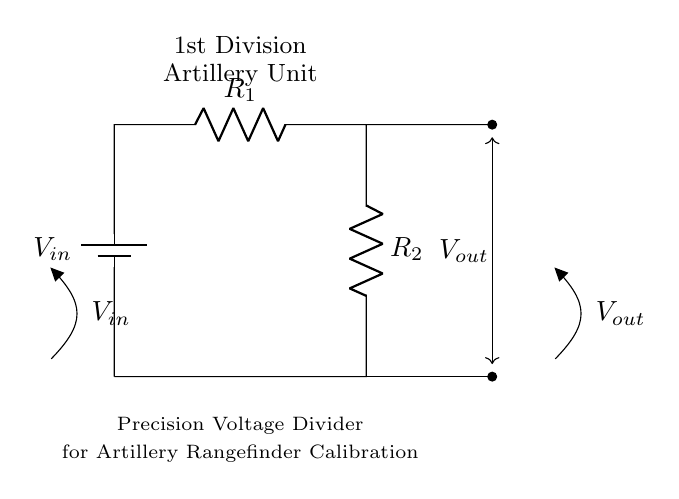What is the input voltage symbol in this circuit? The input voltage symbol is represented as V in the circuit diagram, which denotes the voltage supplied to the voltage divider.
Answer: V in What are the resistances in this precision voltage divider? The circuit shows two resistors connected in series, indicated as R1 and R2. These resistances are integral to determining the output voltage across R2.
Answer: R1, R2 What is the relationship between output voltage and input voltage? The output voltage V out is given by the formula: V out = (R2 / (R1 + R2)) * V in. This establishes how the division of input voltage occurs across the resistors based on their values.
Answer: Divider formula Where is the output voltage taken from in the circuit? The output voltage V out is taken between the two resistors, specifically across R2, as shown in the circuit connections.
Answer: Across R2 What type of circuit is this? This is a voltage divider circuit, which is specifically designed to output a fraction of the input voltage for various applications, including calibration in military equipment.
Answer: Voltage divider Why is precision important in this voltage divider? Precision is crucial for the accuracy of rangefinder calibration, which is essential in artillery units for ensuring correct targeting and distances measurement.
Answer: Accuracy What does the notation "1st Division Artillery Unit" signify? This notation indicates the specific military unit that the circuit is designed for, linking its purpose to the artillery operations of that division.
Answer: Military unit 